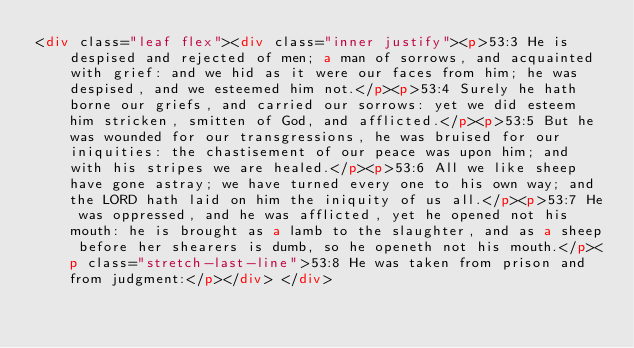Convert code to text. <code><loc_0><loc_0><loc_500><loc_500><_HTML_><div class="leaf flex"><div class="inner justify"><p>53:3 He is despised and rejected of men; a man of sorrows, and acquainted with grief: and we hid as it were our faces from him; he was despised, and we esteemed him not.</p><p>53:4 Surely he hath borne our griefs, and carried our sorrows: yet we did esteem him stricken, smitten of God, and afflicted.</p><p>53:5 But he was wounded for our transgressions, he was bruised for our iniquities: the chastisement of our peace was upon him; and with his stripes we are healed.</p><p>53:6 All we like sheep have gone astray; we have turned every one to his own way; and the LORD hath laid on him the iniquity of us all.</p><p>53:7 He was oppressed, and he was afflicted, yet he opened not his mouth: he is brought as a lamb to the slaughter, and as a sheep before her shearers is dumb, so he openeth not his mouth.</p><p class="stretch-last-line">53:8 He was taken from prison and from judgment:</p></div> </div></code> 